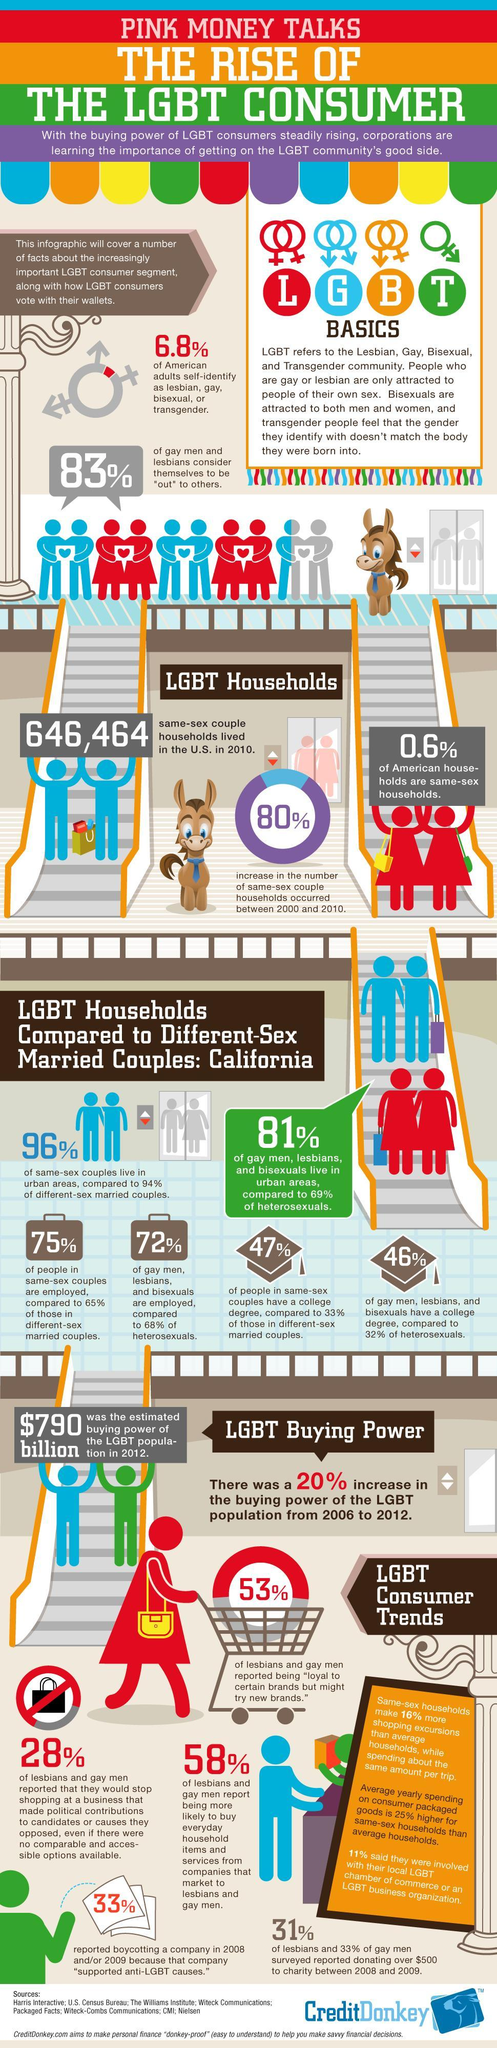What percentage of LGBT boycotted company due to anti-LGBT causes?
Answer the question with a short phrase. 33% What percent of gays and lesbians were loyal to certain brands? 53% What percent of same-sex couples have a college degree in California? 47% What percent of same-sex households increased during 2000 and 201? 80% 